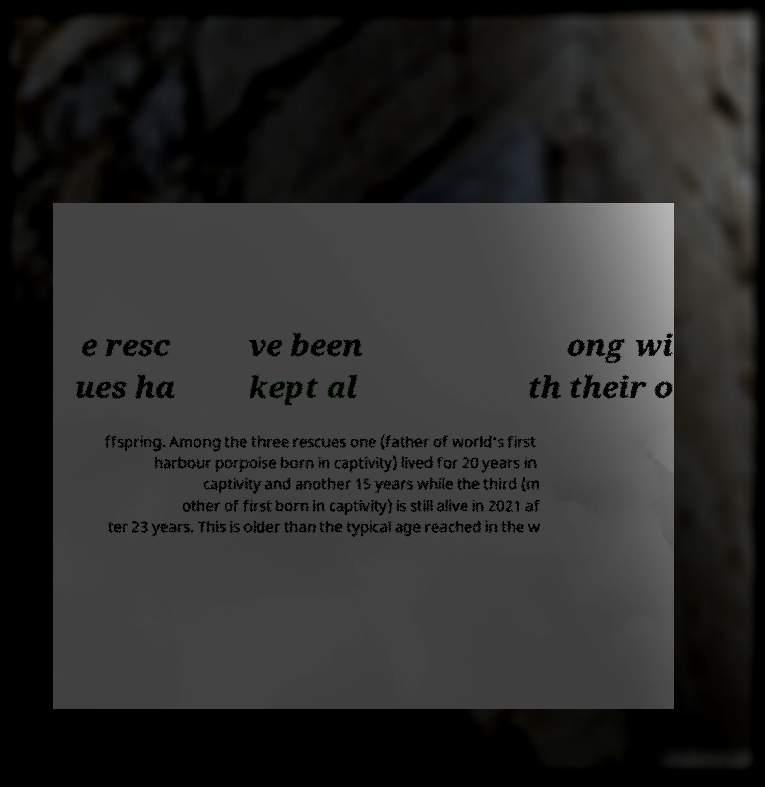For documentation purposes, I need the text within this image transcribed. Could you provide that? e resc ues ha ve been kept al ong wi th their o ffspring. Among the three rescues one (father of world's first harbour porpoise born in captivity) lived for 20 years in captivity and another 15 years while the third (m other of first born in captivity) is still alive in 2021 af ter 23 years. This is older than the typical age reached in the w 